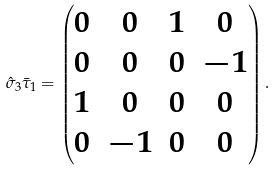Convert formula to latex. <formula><loc_0><loc_0><loc_500><loc_500>\hat { \sigma } _ { 3 } \bar { \tau } _ { 1 } = \begin{pmatrix} 0 & 0 & 1 & 0 \\ 0 & 0 & 0 & - 1 \\ 1 & 0 & 0 & 0 \\ 0 & - 1 & 0 & 0 \end{pmatrix} .</formula> 